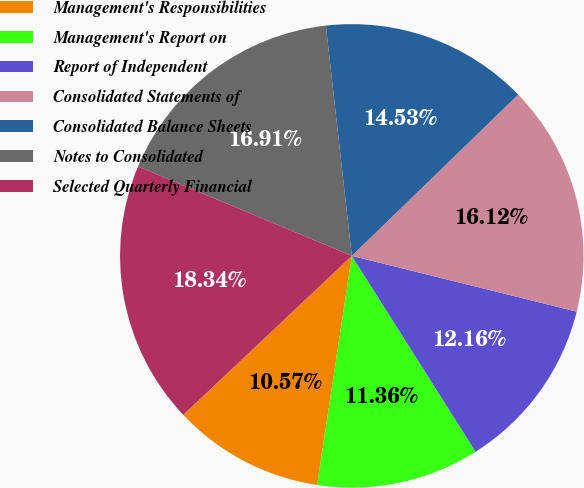Convert chart to OTSL. <chart><loc_0><loc_0><loc_500><loc_500><pie_chart><fcel>Management's Responsibilities<fcel>Management's Report on<fcel>Report of Independent<fcel>Consolidated Statements of<fcel>Consolidated Balance Sheets<fcel>Notes to Consolidated<fcel>Selected Quarterly Financial<nl><fcel>10.57%<fcel>11.36%<fcel>12.16%<fcel>16.12%<fcel>14.53%<fcel>16.91%<fcel>18.34%<nl></chart> 